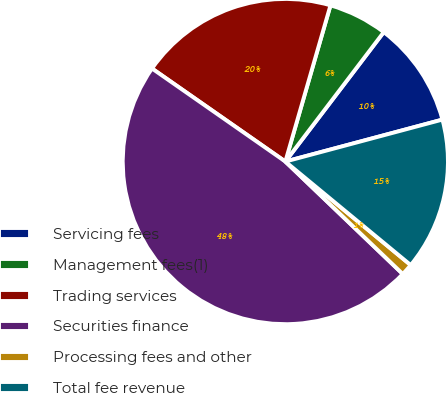<chart> <loc_0><loc_0><loc_500><loc_500><pie_chart><fcel>Servicing fees<fcel>Management fees(1)<fcel>Trading services<fcel>Securities finance<fcel>Processing fees and other<fcel>Total fee revenue<nl><fcel>10.5%<fcel>5.87%<fcel>19.78%<fcel>47.54%<fcel>1.17%<fcel>15.14%<nl></chart> 